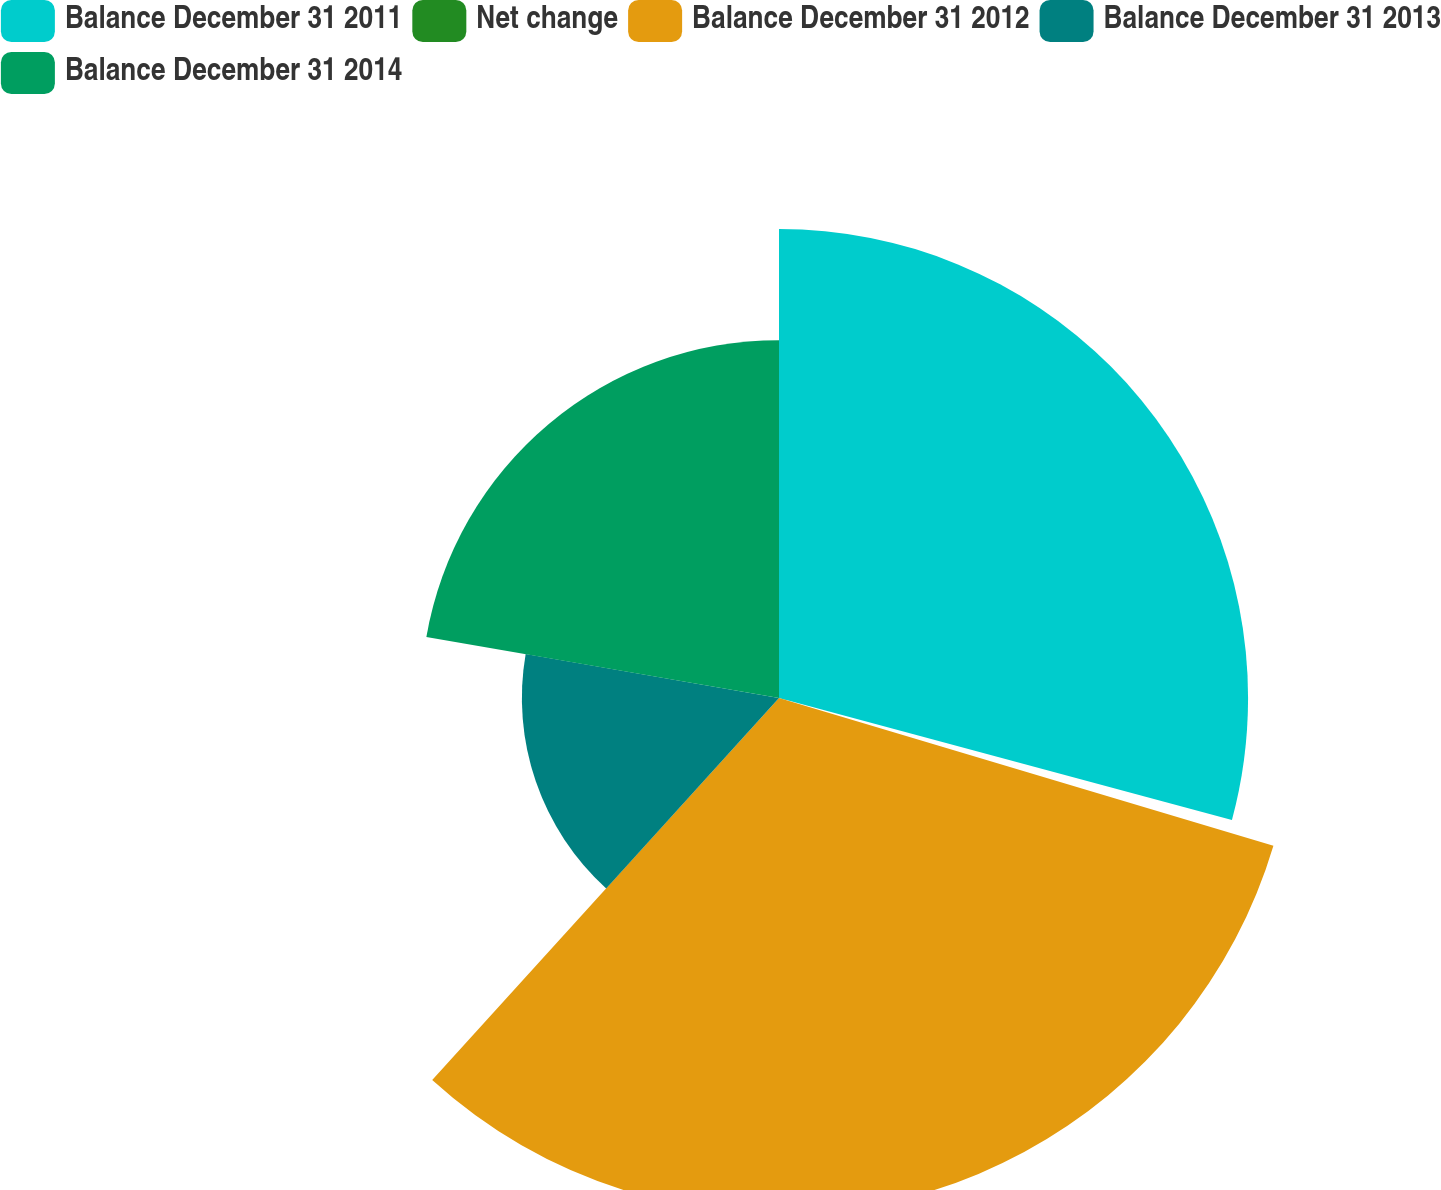<chart> <loc_0><loc_0><loc_500><loc_500><pie_chart><fcel>Balance December 31 2011<fcel>Net change<fcel>Balance December 31 2012<fcel>Balance December 31 2013<fcel>Balance December 31 2014<nl><fcel>29.19%<fcel>0.43%<fcel>32.11%<fcel>16.0%<fcel>22.27%<nl></chart> 